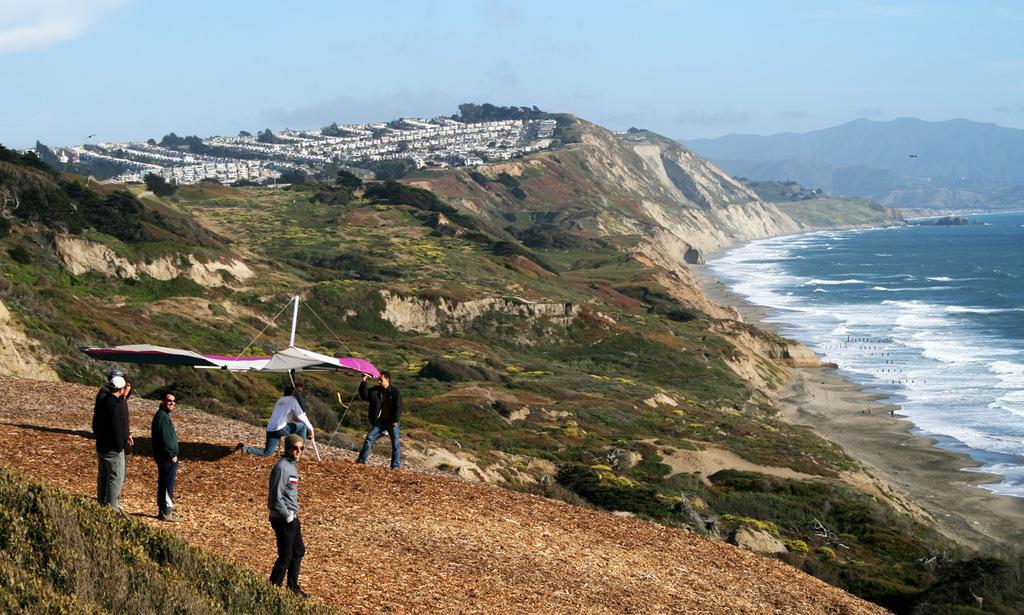How would you summarize this image in a sentence or two? In this picture I can see few people are standing on the rocks, side I can see water flow and some trees. 